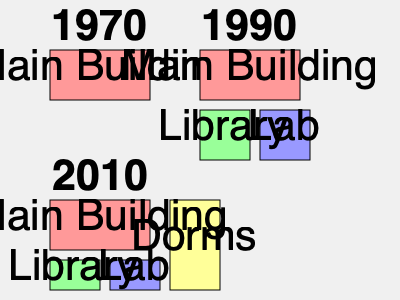Based on the simplified campus maps shown for 1970, 1990, and 2010, which new facility was added to the DMU campus between 1990 and 2010? To answer this question, we need to analyze the changes in the campus layout across the three time periods shown:

1. In 1970, the campus consisted of only the Main Building.

2. By 1990, two new facilities were added:
   - A Library (green rectangle)
   - A Lab (blue rectangle)

3. In 2010, we can observe the following:
   - The Main Building is still present
   - The Library and Lab are still part of the campus
   - A new yellow rectangular building labeled "Dorms" has been added

By comparing the 1990 and 2010 layouts, we can see that the Dorms facility is the only new addition to the campus during this period.
Answer: Dorms 